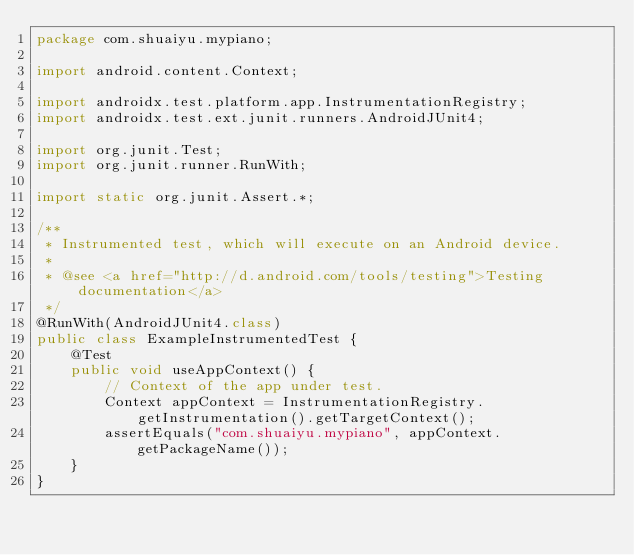Convert code to text. <code><loc_0><loc_0><loc_500><loc_500><_Java_>package com.shuaiyu.mypiano;

import android.content.Context;

import androidx.test.platform.app.InstrumentationRegistry;
import androidx.test.ext.junit.runners.AndroidJUnit4;

import org.junit.Test;
import org.junit.runner.RunWith;

import static org.junit.Assert.*;

/**
 * Instrumented test, which will execute on an Android device.
 *
 * @see <a href="http://d.android.com/tools/testing">Testing documentation</a>
 */
@RunWith(AndroidJUnit4.class)
public class ExampleInstrumentedTest {
    @Test
    public void useAppContext() {
        // Context of the app under test.
        Context appContext = InstrumentationRegistry.getInstrumentation().getTargetContext();
        assertEquals("com.shuaiyu.mypiano", appContext.getPackageName());
    }
}</code> 